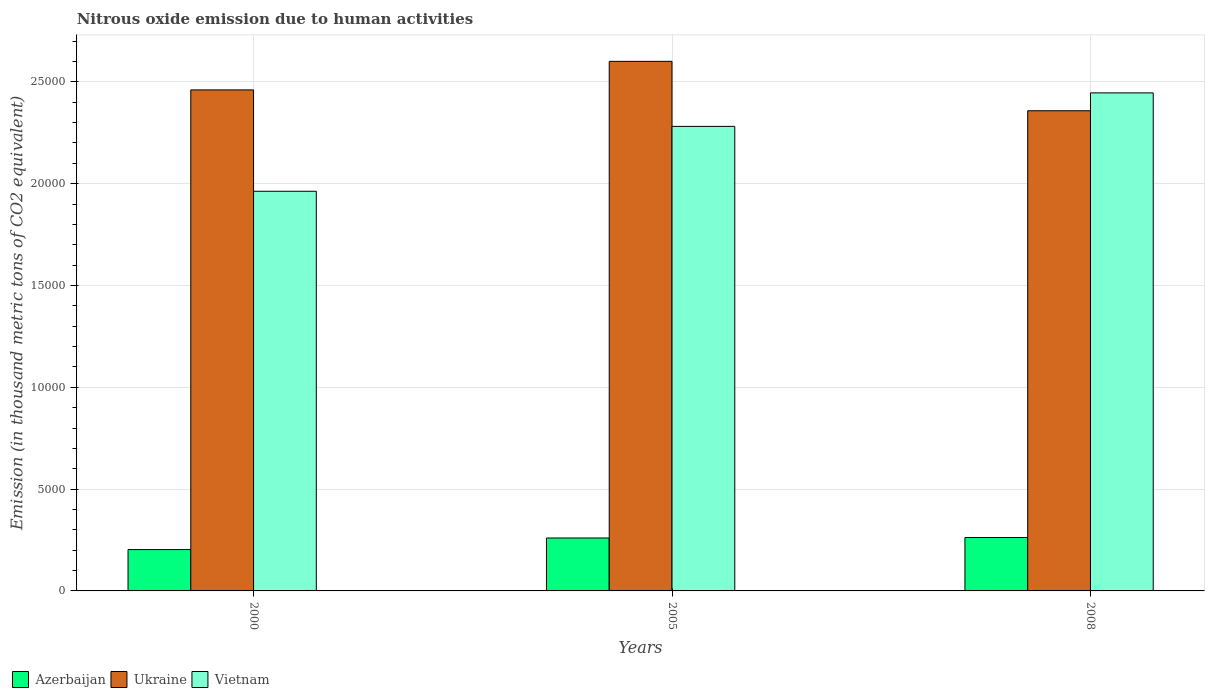How many groups of bars are there?
Provide a short and direct response. 3. Are the number of bars per tick equal to the number of legend labels?
Keep it short and to the point. Yes. How many bars are there on the 2nd tick from the left?
Your answer should be very brief. 3. What is the amount of nitrous oxide emitted in Vietnam in 2000?
Provide a short and direct response. 1.96e+04. Across all years, what is the maximum amount of nitrous oxide emitted in Ukraine?
Your answer should be compact. 2.60e+04. Across all years, what is the minimum amount of nitrous oxide emitted in Azerbaijan?
Give a very brief answer. 2031.7. In which year was the amount of nitrous oxide emitted in Vietnam minimum?
Ensure brevity in your answer.  2000. What is the total amount of nitrous oxide emitted in Azerbaijan in the graph?
Your response must be concise. 7253.7. What is the difference between the amount of nitrous oxide emitted in Vietnam in 2005 and that in 2008?
Offer a terse response. -1645.4. What is the difference between the amount of nitrous oxide emitted in Ukraine in 2008 and the amount of nitrous oxide emitted in Azerbaijan in 2005?
Make the answer very short. 2.10e+04. What is the average amount of nitrous oxide emitted in Vietnam per year?
Give a very brief answer. 2.23e+04. In the year 2000, what is the difference between the amount of nitrous oxide emitted in Ukraine and amount of nitrous oxide emitted in Vietnam?
Your answer should be very brief. 4978.8. In how many years, is the amount of nitrous oxide emitted in Ukraine greater than 26000 thousand metric tons?
Give a very brief answer. 1. What is the ratio of the amount of nitrous oxide emitted in Ukraine in 2000 to that in 2008?
Your answer should be very brief. 1.04. Is the amount of nitrous oxide emitted in Azerbaijan in 2005 less than that in 2008?
Your answer should be very brief. Yes. Is the difference between the amount of nitrous oxide emitted in Ukraine in 2000 and 2005 greater than the difference between the amount of nitrous oxide emitted in Vietnam in 2000 and 2005?
Your answer should be compact. Yes. What is the difference between the highest and the second highest amount of nitrous oxide emitted in Ukraine?
Make the answer very short. 1402.1. What is the difference between the highest and the lowest amount of nitrous oxide emitted in Vietnam?
Your response must be concise. 4832.2. Is the sum of the amount of nitrous oxide emitted in Azerbaijan in 2000 and 2008 greater than the maximum amount of nitrous oxide emitted in Ukraine across all years?
Make the answer very short. No. What does the 2nd bar from the left in 2000 represents?
Ensure brevity in your answer.  Ukraine. What does the 1st bar from the right in 2008 represents?
Make the answer very short. Vietnam. How many years are there in the graph?
Offer a terse response. 3. Are the values on the major ticks of Y-axis written in scientific E-notation?
Make the answer very short. No. Does the graph contain any zero values?
Offer a terse response. No. Where does the legend appear in the graph?
Your response must be concise. Bottom left. What is the title of the graph?
Your answer should be very brief. Nitrous oxide emission due to human activities. Does "Guam" appear as one of the legend labels in the graph?
Offer a very short reply. No. What is the label or title of the X-axis?
Offer a very short reply. Years. What is the label or title of the Y-axis?
Your answer should be compact. Emission (in thousand metric tons of CO2 equivalent). What is the Emission (in thousand metric tons of CO2 equivalent) in Azerbaijan in 2000?
Give a very brief answer. 2031.7. What is the Emission (in thousand metric tons of CO2 equivalent) of Ukraine in 2000?
Your answer should be compact. 2.46e+04. What is the Emission (in thousand metric tons of CO2 equivalent) of Vietnam in 2000?
Offer a terse response. 1.96e+04. What is the Emission (in thousand metric tons of CO2 equivalent) of Azerbaijan in 2005?
Keep it short and to the point. 2599.6. What is the Emission (in thousand metric tons of CO2 equivalent) in Ukraine in 2005?
Keep it short and to the point. 2.60e+04. What is the Emission (in thousand metric tons of CO2 equivalent) in Vietnam in 2005?
Ensure brevity in your answer.  2.28e+04. What is the Emission (in thousand metric tons of CO2 equivalent) in Azerbaijan in 2008?
Provide a succinct answer. 2622.4. What is the Emission (in thousand metric tons of CO2 equivalent) in Ukraine in 2008?
Offer a very short reply. 2.36e+04. What is the Emission (in thousand metric tons of CO2 equivalent) of Vietnam in 2008?
Offer a terse response. 2.45e+04. Across all years, what is the maximum Emission (in thousand metric tons of CO2 equivalent) of Azerbaijan?
Offer a very short reply. 2622.4. Across all years, what is the maximum Emission (in thousand metric tons of CO2 equivalent) of Ukraine?
Provide a succinct answer. 2.60e+04. Across all years, what is the maximum Emission (in thousand metric tons of CO2 equivalent) in Vietnam?
Your answer should be compact. 2.45e+04. Across all years, what is the minimum Emission (in thousand metric tons of CO2 equivalent) in Azerbaijan?
Give a very brief answer. 2031.7. Across all years, what is the minimum Emission (in thousand metric tons of CO2 equivalent) in Ukraine?
Provide a short and direct response. 2.36e+04. Across all years, what is the minimum Emission (in thousand metric tons of CO2 equivalent) in Vietnam?
Offer a terse response. 1.96e+04. What is the total Emission (in thousand metric tons of CO2 equivalent) in Azerbaijan in the graph?
Provide a short and direct response. 7253.7. What is the total Emission (in thousand metric tons of CO2 equivalent) in Ukraine in the graph?
Give a very brief answer. 7.42e+04. What is the total Emission (in thousand metric tons of CO2 equivalent) in Vietnam in the graph?
Your answer should be very brief. 6.69e+04. What is the difference between the Emission (in thousand metric tons of CO2 equivalent) of Azerbaijan in 2000 and that in 2005?
Make the answer very short. -567.9. What is the difference between the Emission (in thousand metric tons of CO2 equivalent) in Ukraine in 2000 and that in 2005?
Ensure brevity in your answer.  -1402.1. What is the difference between the Emission (in thousand metric tons of CO2 equivalent) of Vietnam in 2000 and that in 2005?
Your answer should be compact. -3186.8. What is the difference between the Emission (in thousand metric tons of CO2 equivalent) in Azerbaijan in 2000 and that in 2008?
Ensure brevity in your answer.  -590.7. What is the difference between the Emission (in thousand metric tons of CO2 equivalent) in Ukraine in 2000 and that in 2008?
Make the answer very short. 1024.6. What is the difference between the Emission (in thousand metric tons of CO2 equivalent) of Vietnam in 2000 and that in 2008?
Offer a very short reply. -4832.2. What is the difference between the Emission (in thousand metric tons of CO2 equivalent) of Azerbaijan in 2005 and that in 2008?
Your answer should be compact. -22.8. What is the difference between the Emission (in thousand metric tons of CO2 equivalent) of Ukraine in 2005 and that in 2008?
Your answer should be compact. 2426.7. What is the difference between the Emission (in thousand metric tons of CO2 equivalent) in Vietnam in 2005 and that in 2008?
Your response must be concise. -1645.4. What is the difference between the Emission (in thousand metric tons of CO2 equivalent) of Azerbaijan in 2000 and the Emission (in thousand metric tons of CO2 equivalent) of Ukraine in 2005?
Provide a short and direct response. -2.40e+04. What is the difference between the Emission (in thousand metric tons of CO2 equivalent) of Azerbaijan in 2000 and the Emission (in thousand metric tons of CO2 equivalent) of Vietnam in 2005?
Your answer should be compact. -2.08e+04. What is the difference between the Emission (in thousand metric tons of CO2 equivalent) of Ukraine in 2000 and the Emission (in thousand metric tons of CO2 equivalent) of Vietnam in 2005?
Offer a very short reply. 1792. What is the difference between the Emission (in thousand metric tons of CO2 equivalent) in Azerbaijan in 2000 and the Emission (in thousand metric tons of CO2 equivalent) in Ukraine in 2008?
Your answer should be very brief. -2.15e+04. What is the difference between the Emission (in thousand metric tons of CO2 equivalent) of Azerbaijan in 2000 and the Emission (in thousand metric tons of CO2 equivalent) of Vietnam in 2008?
Provide a succinct answer. -2.24e+04. What is the difference between the Emission (in thousand metric tons of CO2 equivalent) of Ukraine in 2000 and the Emission (in thousand metric tons of CO2 equivalent) of Vietnam in 2008?
Your answer should be compact. 146.6. What is the difference between the Emission (in thousand metric tons of CO2 equivalent) of Azerbaijan in 2005 and the Emission (in thousand metric tons of CO2 equivalent) of Ukraine in 2008?
Ensure brevity in your answer.  -2.10e+04. What is the difference between the Emission (in thousand metric tons of CO2 equivalent) in Azerbaijan in 2005 and the Emission (in thousand metric tons of CO2 equivalent) in Vietnam in 2008?
Your answer should be very brief. -2.19e+04. What is the difference between the Emission (in thousand metric tons of CO2 equivalent) of Ukraine in 2005 and the Emission (in thousand metric tons of CO2 equivalent) of Vietnam in 2008?
Offer a very short reply. 1548.7. What is the average Emission (in thousand metric tons of CO2 equivalent) in Azerbaijan per year?
Provide a succinct answer. 2417.9. What is the average Emission (in thousand metric tons of CO2 equivalent) in Ukraine per year?
Your answer should be very brief. 2.47e+04. What is the average Emission (in thousand metric tons of CO2 equivalent) of Vietnam per year?
Your answer should be compact. 2.23e+04. In the year 2000, what is the difference between the Emission (in thousand metric tons of CO2 equivalent) in Azerbaijan and Emission (in thousand metric tons of CO2 equivalent) in Ukraine?
Make the answer very short. -2.26e+04. In the year 2000, what is the difference between the Emission (in thousand metric tons of CO2 equivalent) of Azerbaijan and Emission (in thousand metric tons of CO2 equivalent) of Vietnam?
Ensure brevity in your answer.  -1.76e+04. In the year 2000, what is the difference between the Emission (in thousand metric tons of CO2 equivalent) of Ukraine and Emission (in thousand metric tons of CO2 equivalent) of Vietnam?
Provide a succinct answer. 4978.8. In the year 2005, what is the difference between the Emission (in thousand metric tons of CO2 equivalent) in Azerbaijan and Emission (in thousand metric tons of CO2 equivalent) in Ukraine?
Your answer should be very brief. -2.34e+04. In the year 2005, what is the difference between the Emission (in thousand metric tons of CO2 equivalent) of Azerbaijan and Emission (in thousand metric tons of CO2 equivalent) of Vietnam?
Provide a succinct answer. -2.02e+04. In the year 2005, what is the difference between the Emission (in thousand metric tons of CO2 equivalent) in Ukraine and Emission (in thousand metric tons of CO2 equivalent) in Vietnam?
Your response must be concise. 3194.1. In the year 2008, what is the difference between the Emission (in thousand metric tons of CO2 equivalent) of Azerbaijan and Emission (in thousand metric tons of CO2 equivalent) of Ukraine?
Ensure brevity in your answer.  -2.10e+04. In the year 2008, what is the difference between the Emission (in thousand metric tons of CO2 equivalent) of Azerbaijan and Emission (in thousand metric tons of CO2 equivalent) of Vietnam?
Your answer should be very brief. -2.18e+04. In the year 2008, what is the difference between the Emission (in thousand metric tons of CO2 equivalent) in Ukraine and Emission (in thousand metric tons of CO2 equivalent) in Vietnam?
Provide a short and direct response. -878. What is the ratio of the Emission (in thousand metric tons of CO2 equivalent) of Azerbaijan in 2000 to that in 2005?
Offer a terse response. 0.78. What is the ratio of the Emission (in thousand metric tons of CO2 equivalent) in Ukraine in 2000 to that in 2005?
Make the answer very short. 0.95. What is the ratio of the Emission (in thousand metric tons of CO2 equivalent) in Vietnam in 2000 to that in 2005?
Your answer should be compact. 0.86. What is the ratio of the Emission (in thousand metric tons of CO2 equivalent) of Azerbaijan in 2000 to that in 2008?
Offer a terse response. 0.77. What is the ratio of the Emission (in thousand metric tons of CO2 equivalent) of Ukraine in 2000 to that in 2008?
Offer a very short reply. 1.04. What is the ratio of the Emission (in thousand metric tons of CO2 equivalent) of Vietnam in 2000 to that in 2008?
Ensure brevity in your answer.  0.8. What is the ratio of the Emission (in thousand metric tons of CO2 equivalent) of Azerbaijan in 2005 to that in 2008?
Your answer should be very brief. 0.99. What is the ratio of the Emission (in thousand metric tons of CO2 equivalent) of Ukraine in 2005 to that in 2008?
Keep it short and to the point. 1.1. What is the ratio of the Emission (in thousand metric tons of CO2 equivalent) of Vietnam in 2005 to that in 2008?
Offer a very short reply. 0.93. What is the difference between the highest and the second highest Emission (in thousand metric tons of CO2 equivalent) of Azerbaijan?
Keep it short and to the point. 22.8. What is the difference between the highest and the second highest Emission (in thousand metric tons of CO2 equivalent) of Ukraine?
Your response must be concise. 1402.1. What is the difference between the highest and the second highest Emission (in thousand metric tons of CO2 equivalent) in Vietnam?
Your answer should be very brief. 1645.4. What is the difference between the highest and the lowest Emission (in thousand metric tons of CO2 equivalent) in Azerbaijan?
Ensure brevity in your answer.  590.7. What is the difference between the highest and the lowest Emission (in thousand metric tons of CO2 equivalent) in Ukraine?
Provide a succinct answer. 2426.7. What is the difference between the highest and the lowest Emission (in thousand metric tons of CO2 equivalent) in Vietnam?
Provide a short and direct response. 4832.2. 